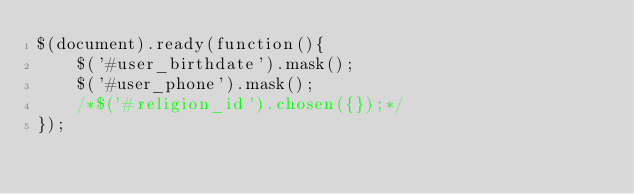Convert code to text. <code><loc_0><loc_0><loc_500><loc_500><_PHP_>$(document).ready(function(){
    $('#user_birthdate').mask();
    $('#user_phone').mask();
    /*$('#religion_id').chosen({});*/
});</code> 